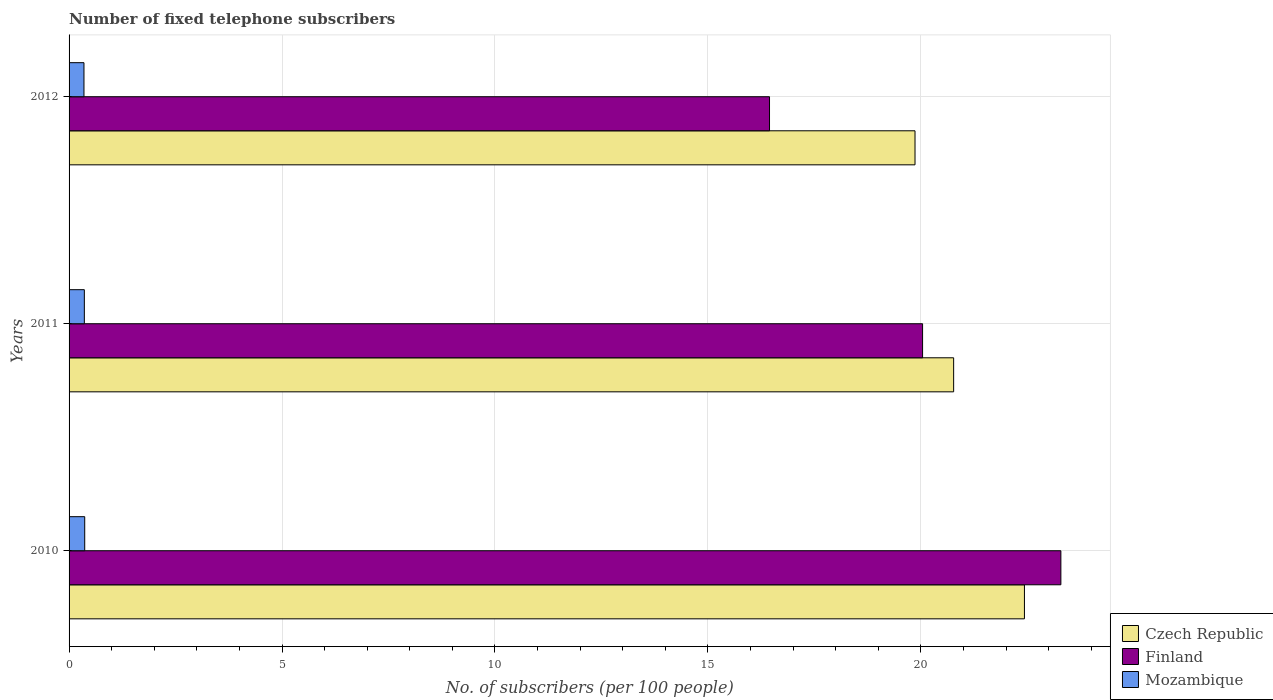How many different coloured bars are there?
Keep it short and to the point. 3. How many groups of bars are there?
Offer a very short reply. 3. How many bars are there on the 3rd tick from the top?
Offer a very short reply. 3. How many bars are there on the 2nd tick from the bottom?
Your answer should be compact. 3. What is the label of the 1st group of bars from the top?
Keep it short and to the point. 2012. In how many cases, is the number of bars for a given year not equal to the number of legend labels?
Give a very brief answer. 0. What is the number of fixed telephone subscribers in Finland in 2010?
Provide a succinct answer. 23.29. Across all years, what is the maximum number of fixed telephone subscribers in Czech Republic?
Provide a short and direct response. 22.43. Across all years, what is the minimum number of fixed telephone subscribers in Mozambique?
Your answer should be very brief. 0.35. What is the total number of fixed telephone subscribers in Finland in the graph?
Make the answer very short. 59.77. What is the difference between the number of fixed telephone subscribers in Czech Republic in 2011 and that in 2012?
Offer a very short reply. 0.91. What is the difference between the number of fixed telephone subscribers in Czech Republic in 2010 and the number of fixed telephone subscribers in Mozambique in 2012?
Your answer should be compact. 22.08. What is the average number of fixed telephone subscribers in Czech Republic per year?
Offer a terse response. 21.02. In the year 2010, what is the difference between the number of fixed telephone subscribers in Finland and number of fixed telephone subscribers in Czech Republic?
Provide a short and direct response. 0.86. What is the ratio of the number of fixed telephone subscribers in Mozambique in 2010 to that in 2012?
Your answer should be compact. 1.05. What is the difference between the highest and the second highest number of fixed telephone subscribers in Czech Republic?
Provide a short and direct response. 1.66. What is the difference between the highest and the lowest number of fixed telephone subscribers in Czech Republic?
Provide a succinct answer. 2.57. In how many years, is the number of fixed telephone subscribers in Czech Republic greater than the average number of fixed telephone subscribers in Czech Republic taken over all years?
Make the answer very short. 1. Is the sum of the number of fixed telephone subscribers in Czech Republic in 2010 and 2012 greater than the maximum number of fixed telephone subscribers in Mozambique across all years?
Give a very brief answer. Yes. What does the 1st bar from the top in 2011 represents?
Make the answer very short. Mozambique. What does the 3rd bar from the bottom in 2010 represents?
Provide a short and direct response. Mozambique. Are all the bars in the graph horizontal?
Keep it short and to the point. Yes. How many years are there in the graph?
Provide a short and direct response. 3. What is the difference between two consecutive major ticks on the X-axis?
Your answer should be compact. 5. Does the graph contain grids?
Provide a short and direct response. Yes. Where does the legend appear in the graph?
Keep it short and to the point. Bottom right. What is the title of the graph?
Give a very brief answer. Number of fixed telephone subscribers. Does "Puerto Rico" appear as one of the legend labels in the graph?
Ensure brevity in your answer.  No. What is the label or title of the X-axis?
Provide a succinct answer. No. of subscribers (per 100 people). What is the label or title of the Y-axis?
Offer a very short reply. Years. What is the No. of subscribers (per 100 people) of Czech Republic in 2010?
Your answer should be compact. 22.43. What is the No. of subscribers (per 100 people) of Finland in 2010?
Offer a very short reply. 23.29. What is the No. of subscribers (per 100 people) of Mozambique in 2010?
Make the answer very short. 0.37. What is the No. of subscribers (per 100 people) in Czech Republic in 2011?
Keep it short and to the point. 20.77. What is the No. of subscribers (per 100 people) in Finland in 2011?
Your answer should be compact. 20.04. What is the No. of subscribers (per 100 people) of Mozambique in 2011?
Make the answer very short. 0.36. What is the No. of subscribers (per 100 people) in Czech Republic in 2012?
Give a very brief answer. 19.86. What is the No. of subscribers (per 100 people) of Finland in 2012?
Provide a succinct answer. 16.45. What is the No. of subscribers (per 100 people) of Mozambique in 2012?
Provide a short and direct response. 0.35. Across all years, what is the maximum No. of subscribers (per 100 people) of Czech Republic?
Offer a very short reply. 22.43. Across all years, what is the maximum No. of subscribers (per 100 people) of Finland?
Ensure brevity in your answer.  23.29. Across all years, what is the maximum No. of subscribers (per 100 people) of Mozambique?
Offer a terse response. 0.37. Across all years, what is the minimum No. of subscribers (per 100 people) of Czech Republic?
Give a very brief answer. 19.86. Across all years, what is the minimum No. of subscribers (per 100 people) in Finland?
Offer a terse response. 16.45. Across all years, what is the minimum No. of subscribers (per 100 people) in Mozambique?
Provide a succinct answer. 0.35. What is the total No. of subscribers (per 100 people) of Czech Republic in the graph?
Your response must be concise. 63.06. What is the total No. of subscribers (per 100 people) of Finland in the graph?
Your response must be concise. 59.77. What is the total No. of subscribers (per 100 people) of Mozambique in the graph?
Provide a succinct answer. 1.08. What is the difference between the No. of subscribers (per 100 people) of Czech Republic in 2010 and that in 2011?
Your answer should be very brief. 1.66. What is the difference between the No. of subscribers (per 100 people) in Finland in 2010 and that in 2011?
Your answer should be compact. 3.25. What is the difference between the No. of subscribers (per 100 people) in Mozambique in 2010 and that in 2011?
Make the answer very short. 0.01. What is the difference between the No. of subscribers (per 100 people) of Czech Republic in 2010 and that in 2012?
Provide a succinct answer. 2.57. What is the difference between the No. of subscribers (per 100 people) in Finland in 2010 and that in 2012?
Make the answer very short. 6.84. What is the difference between the No. of subscribers (per 100 people) of Mozambique in 2010 and that in 2012?
Offer a terse response. 0.02. What is the difference between the No. of subscribers (per 100 people) in Czech Republic in 2011 and that in 2012?
Your response must be concise. 0.91. What is the difference between the No. of subscribers (per 100 people) of Finland in 2011 and that in 2012?
Ensure brevity in your answer.  3.59. What is the difference between the No. of subscribers (per 100 people) in Mozambique in 2011 and that in 2012?
Provide a short and direct response. 0.01. What is the difference between the No. of subscribers (per 100 people) in Czech Republic in 2010 and the No. of subscribers (per 100 people) in Finland in 2011?
Provide a succinct answer. 2.39. What is the difference between the No. of subscribers (per 100 people) of Czech Republic in 2010 and the No. of subscribers (per 100 people) of Mozambique in 2011?
Your answer should be compact. 22.07. What is the difference between the No. of subscribers (per 100 people) in Finland in 2010 and the No. of subscribers (per 100 people) in Mozambique in 2011?
Offer a terse response. 22.93. What is the difference between the No. of subscribers (per 100 people) of Czech Republic in 2010 and the No. of subscribers (per 100 people) of Finland in 2012?
Provide a succinct answer. 5.99. What is the difference between the No. of subscribers (per 100 people) in Czech Republic in 2010 and the No. of subscribers (per 100 people) in Mozambique in 2012?
Provide a short and direct response. 22.08. What is the difference between the No. of subscribers (per 100 people) in Finland in 2010 and the No. of subscribers (per 100 people) in Mozambique in 2012?
Make the answer very short. 22.94. What is the difference between the No. of subscribers (per 100 people) in Czech Republic in 2011 and the No. of subscribers (per 100 people) in Finland in 2012?
Ensure brevity in your answer.  4.32. What is the difference between the No. of subscribers (per 100 people) in Czech Republic in 2011 and the No. of subscribers (per 100 people) in Mozambique in 2012?
Your answer should be very brief. 20.42. What is the difference between the No. of subscribers (per 100 people) of Finland in 2011 and the No. of subscribers (per 100 people) of Mozambique in 2012?
Your response must be concise. 19.69. What is the average No. of subscribers (per 100 people) of Czech Republic per year?
Make the answer very short. 21.02. What is the average No. of subscribers (per 100 people) of Finland per year?
Your answer should be compact. 19.92. What is the average No. of subscribers (per 100 people) in Mozambique per year?
Your answer should be very brief. 0.36. In the year 2010, what is the difference between the No. of subscribers (per 100 people) in Czech Republic and No. of subscribers (per 100 people) in Finland?
Provide a short and direct response. -0.86. In the year 2010, what is the difference between the No. of subscribers (per 100 people) in Czech Republic and No. of subscribers (per 100 people) in Mozambique?
Offer a very short reply. 22.06. In the year 2010, what is the difference between the No. of subscribers (per 100 people) in Finland and No. of subscribers (per 100 people) in Mozambique?
Give a very brief answer. 22.92. In the year 2011, what is the difference between the No. of subscribers (per 100 people) in Czech Republic and No. of subscribers (per 100 people) in Finland?
Make the answer very short. 0.73. In the year 2011, what is the difference between the No. of subscribers (per 100 people) in Czech Republic and No. of subscribers (per 100 people) in Mozambique?
Offer a very short reply. 20.41. In the year 2011, what is the difference between the No. of subscribers (per 100 people) of Finland and No. of subscribers (per 100 people) of Mozambique?
Your answer should be very brief. 19.68. In the year 2012, what is the difference between the No. of subscribers (per 100 people) of Czech Republic and No. of subscribers (per 100 people) of Finland?
Your response must be concise. 3.42. In the year 2012, what is the difference between the No. of subscribers (per 100 people) in Czech Republic and No. of subscribers (per 100 people) in Mozambique?
Provide a succinct answer. 19.51. In the year 2012, what is the difference between the No. of subscribers (per 100 people) in Finland and No. of subscribers (per 100 people) in Mozambique?
Your answer should be compact. 16.1. What is the ratio of the No. of subscribers (per 100 people) of Finland in 2010 to that in 2011?
Provide a succinct answer. 1.16. What is the ratio of the No. of subscribers (per 100 people) in Mozambique in 2010 to that in 2011?
Ensure brevity in your answer.  1.02. What is the ratio of the No. of subscribers (per 100 people) of Czech Republic in 2010 to that in 2012?
Your response must be concise. 1.13. What is the ratio of the No. of subscribers (per 100 people) in Finland in 2010 to that in 2012?
Your answer should be compact. 1.42. What is the ratio of the No. of subscribers (per 100 people) of Mozambique in 2010 to that in 2012?
Make the answer very short. 1.05. What is the ratio of the No. of subscribers (per 100 people) of Czech Republic in 2011 to that in 2012?
Offer a terse response. 1.05. What is the ratio of the No. of subscribers (per 100 people) in Finland in 2011 to that in 2012?
Provide a succinct answer. 1.22. What is the ratio of the No. of subscribers (per 100 people) in Mozambique in 2011 to that in 2012?
Ensure brevity in your answer.  1.03. What is the difference between the highest and the second highest No. of subscribers (per 100 people) in Czech Republic?
Keep it short and to the point. 1.66. What is the difference between the highest and the second highest No. of subscribers (per 100 people) of Finland?
Your response must be concise. 3.25. What is the difference between the highest and the second highest No. of subscribers (per 100 people) in Mozambique?
Offer a very short reply. 0.01. What is the difference between the highest and the lowest No. of subscribers (per 100 people) in Czech Republic?
Ensure brevity in your answer.  2.57. What is the difference between the highest and the lowest No. of subscribers (per 100 people) in Finland?
Provide a succinct answer. 6.84. What is the difference between the highest and the lowest No. of subscribers (per 100 people) in Mozambique?
Ensure brevity in your answer.  0.02. 